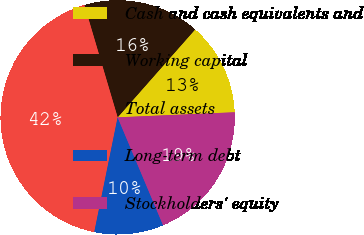<chart> <loc_0><loc_0><loc_500><loc_500><pie_chart><fcel>Cash and cash equivalents and<fcel>Working capital<fcel>Total assets<fcel>Long-term debt<fcel>Stockholders' equity<nl><fcel>12.81%<fcel>16.08%<fcel>42.23%<fcel>9.54%<fcel>19.35%<nl></chart> 